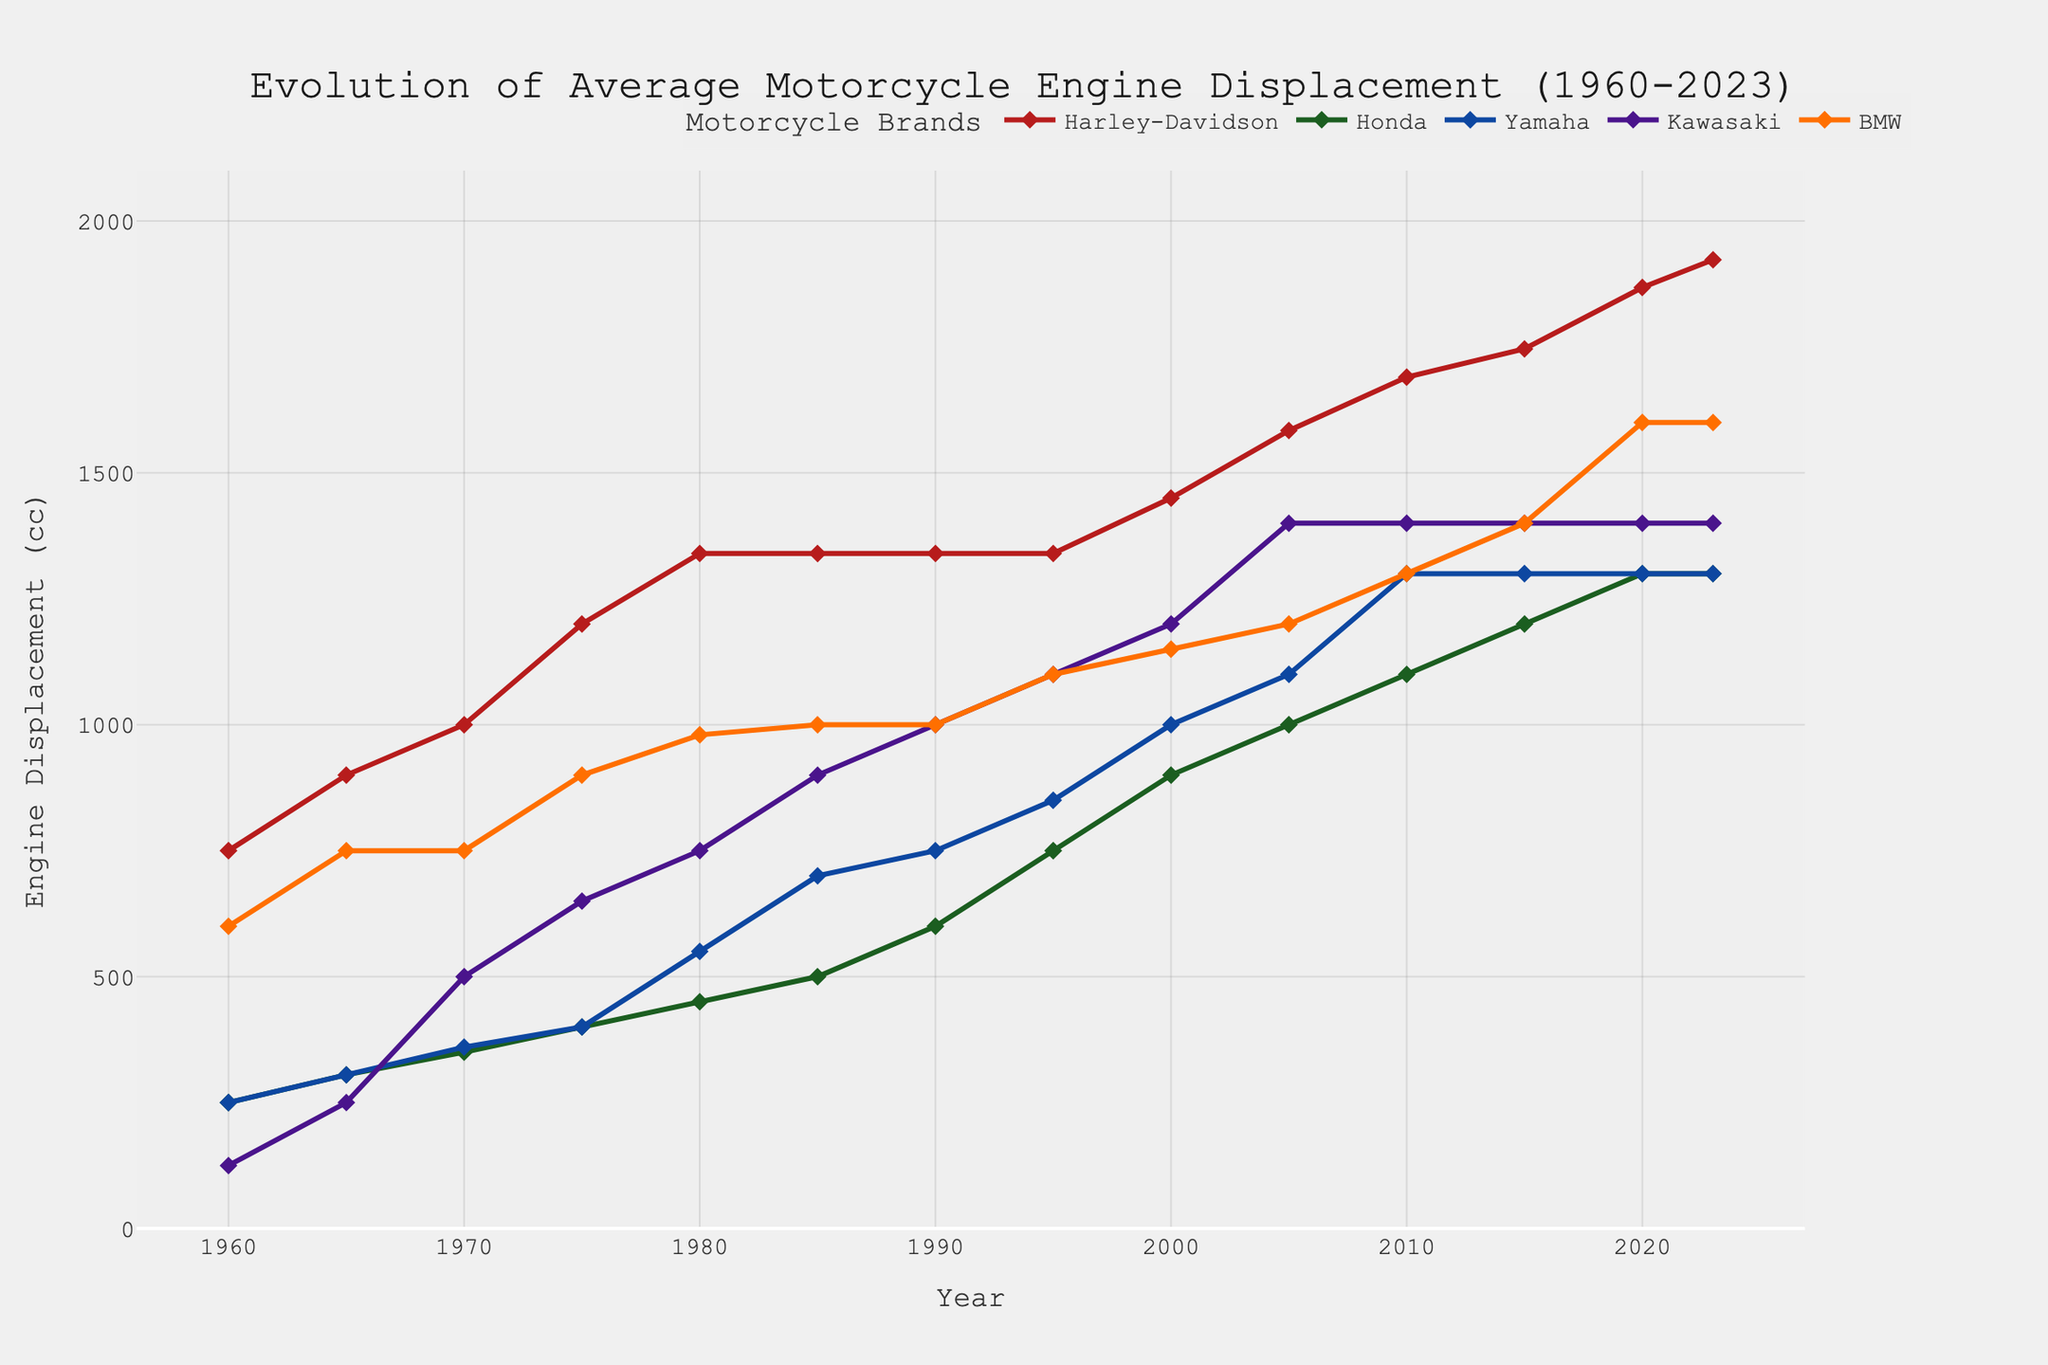What's the largest engine displacement recorded in the chart, and which brand does it belong to? The highest point in the chart shows an engine displacement of 1923 cc for Harley-Davidson in 2023. This can be seen by the height of the red line's last point.
Answer: 1923 cc, Harley-Davidson Which brand had the lowest engine displacement in 1960? To find the lowest displacement in 1960, we compare all brands' values for that year. The lowest value, 125 cc, belongs to Kawasaki.
Answer: Kawasaki, 125 cc How did the engine displacement of BMW change from 1960 to 2023? Looking at the progression of the BMW line from 1960 to 2023, the displacement increased from 600 cc to 1600 cc. This is deduced by tracing the height of the line which went from low in 1960 to the higher position in 2023.
Answer: Increased from 600 cc to 1600 cc Is there any year where all brands have exactly the same engine displacement? By visually scanning the lines across the years, no single year shows all lines converging at the same displacement value, implying no year has all brands with identical displacements.
Answer: No Which brand saw the most significant increase in engine displacement from 1980 to 1990? We calculate the differences from 1980 to 1990 for all brands and see Harley-Davidson increased from 1340 cc to 1340 cc (0 cc), Honda from 450 cc to 600 cc (150 cc), Yamaha from 550 cc to 750 cc (200 cc), Kawasaki from 750 cc to 1000 cc (250 cc), and BMW from 980 cc to 1000 cc (20 cc). Kawasaki shows the largest increase of 250 cc.
Answer: Kawasaki, 250 cc How many brands had engine displacements greater than or equal to 1300 cc in 2023? To answer this, we look at the values for each brand in 2023: Harley-Davidson 1923 cc, Honda 1300 cc, Yamaha 1300 cc, Kawasaki 1400 cc, and BMW 1600 cc. All brands meet or exceed 1300 cc.
Answer: 5 brands Compare the engine displacement trends of Harley-Davidson and Yamaha from 1975 to 2010. From 1975 to 2010, Harley-Davidson's displacement increased from 1200 cc to 1690 cc. Yamaha’s displacement increased from 400 cc to 1300 cc during the same period. Both brands saw an upward trend, but Harley-Davidson always maintained a higher displacement.
Answer: Harley-Davidson increased from 1200 cc to 1690 cc; Yamaha increased from 400 cc to 1300 cc Between 1985 and 2000, which brand had the highest average engine displacement? Calculating the average over the given years, Harley-Davidson: (1340+1340+1450)/3 = 1376.67 cc, Honda: (500+600+750+900)/4 = 687.5 cc, Yamaha: (700+750+850+1000)/4 = 825 cc, Kawasaki: (900+1000+1100+1200)/4 = 1050 cc, BMW: (1000+1100+1150)/4 = 1087.5 cc. BMW has the highest average displacement.
Answer: BMW, 1087.5 cc 